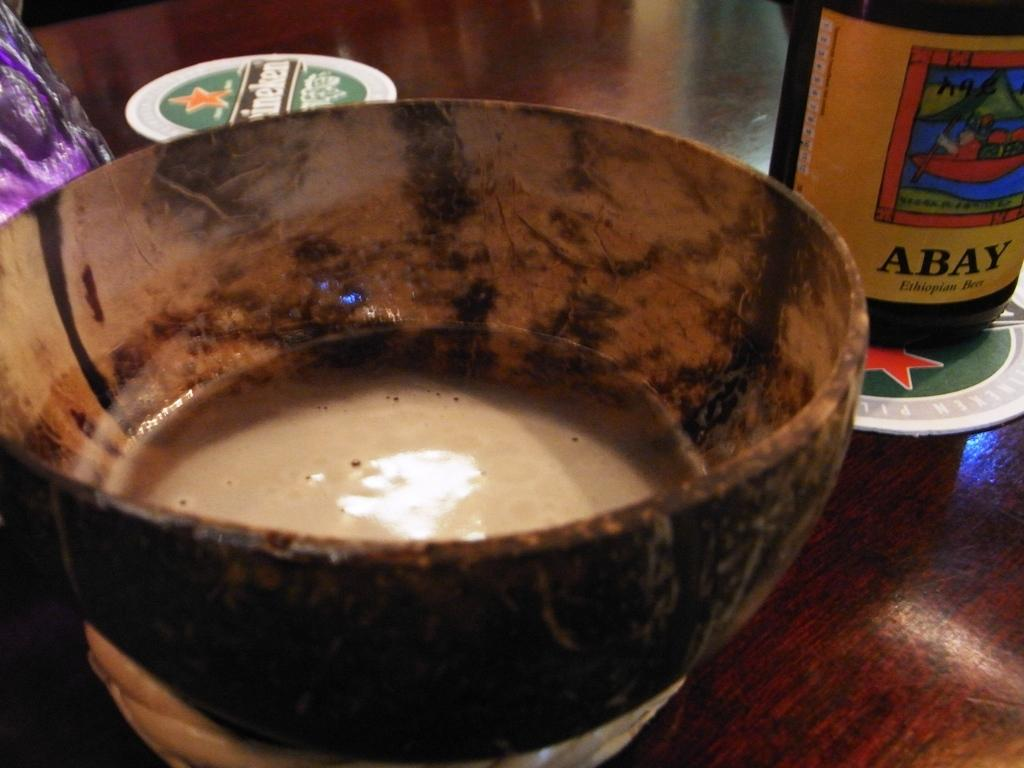What is in the bowl that is visible in the image? There is a bowl with a liquid in the image. What objects are present on the table in the image? There are coasters and a bottle on the table in the image. What might be used to protect the table from moisture or heat in the image? Coasters are present in the image to protect the table. What is the other container visible in the image? There is a bottle in the image. Where is the crown placed on the table in the image? There is no crown present in the image. Can you describe the bee that is buzzing around the bottle in the image? There is no bee present in the image; it only features a bowl with a liquid, coasters, and a bottle on a table. 